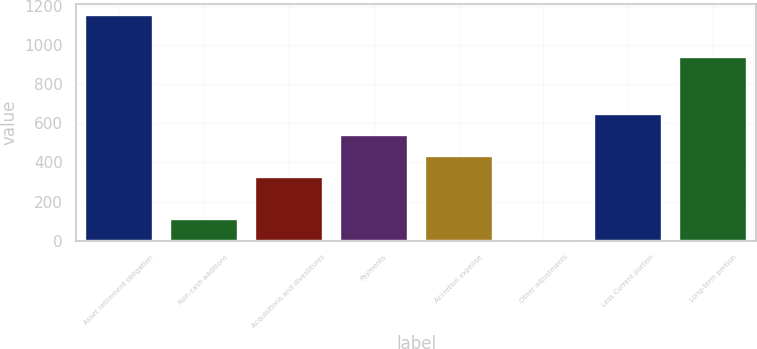Convert chart to OTSL. <chart><loc_0><loc_0><loc_500><loc_500><bar_chart><fcel>Asset retirement obligation<fcel>Non-cash additions<fcel>Acquisitions and divestitures<fcel>Payments<fcel>Accretion expense<fcel>Other adjustments<fcel>Less Current portion<fcel>Long-term portion<nl><fcel>1151.62<fcel>108.71<fcel>323.33<fcel>537.95<fcel>430.64<fcel>1.4<fcel>645.26<fcel>937<nl></chart> 